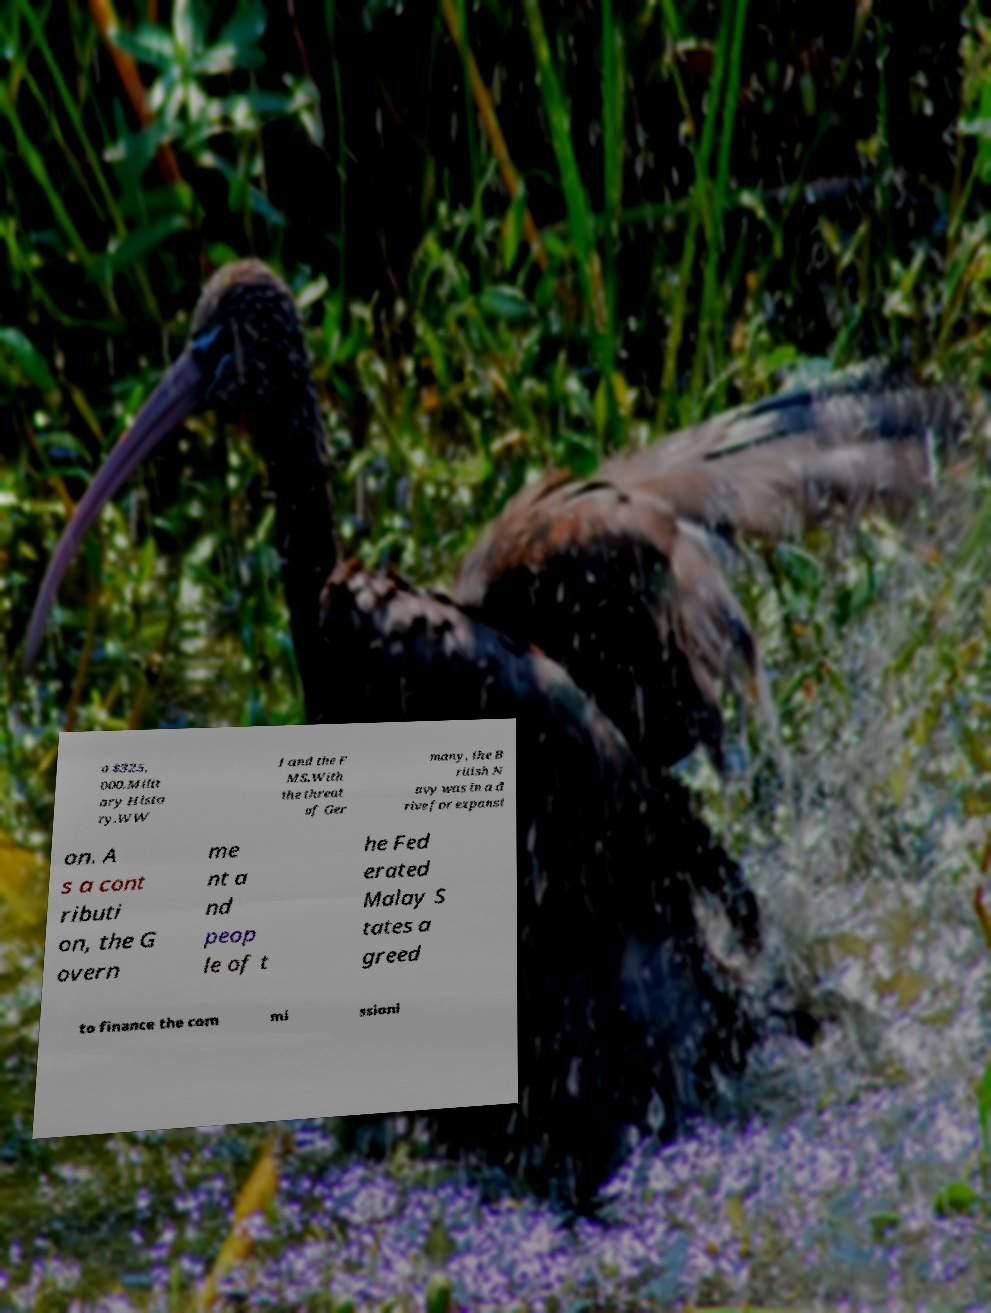Please identify and transcribe the text found in this image. o $325, 000.Milit ary Histo ry.WW I and the F MS.With the threat of Ger many, the B ritish N avy was in a d rive for expansi on. A s a cont ributi on, the G overn me nt a nd peop le of t he Fed erated Malay S tates a greed to finance the com mi ssioni 